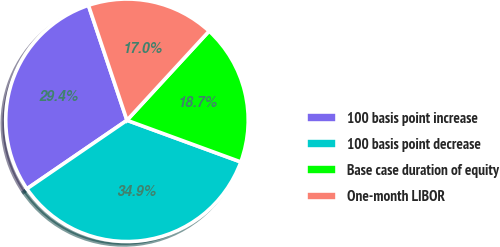<chart> <loc_0><loc_0><loc_500><loc_500><pie_chart><fcel>100 basis point increase<fcel>100 basis point decrease<fcel>Base case duration of equity<fcel>One-month LIBOR<nl><fcel>29.41%<fcel>34.86%<fcel>18.74%<fcel>16.99%<nl></chart> 